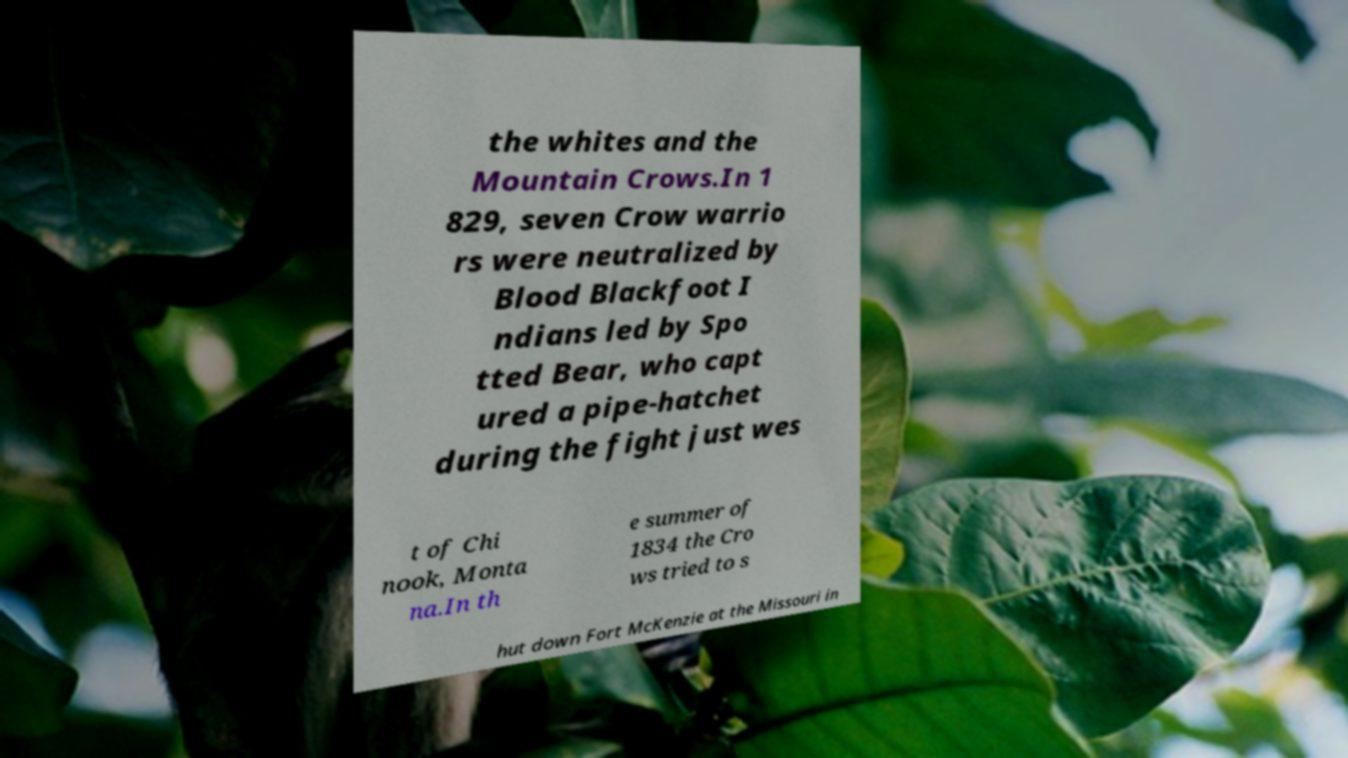Could you assist in decoding the text presented in this image and type it out clearly? the whites and the Mountain Crows.In 1 829, seven Crow warrio rs were neutralized by Blood Blackfoot I ndians led by Spo tted Bear, who capt ured a pipe-hatchet during the fight just wes t of Chi nook, Monta na.In th e summer of 1834 the Cro ws tried to s hut down Fort McKenzie at the Missouri in 